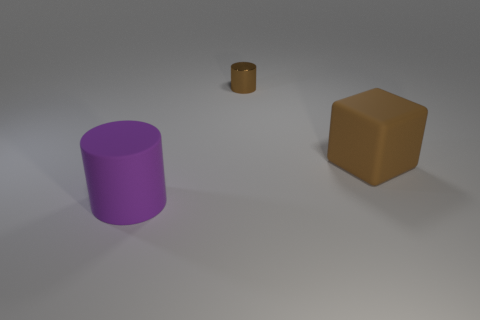Is there any other thing that is made of the same material as the small cylinder?
Make the answer very short. No. Is there any other thing that is the same size as the brown metal cylinder?
Provide a short and direct response. No. What material is the cylinder that is the same size as the brown matte cube?
Provide a short and direct response. Rubber. What shape is the matte object that is behind the object that is on the left side of the brown metal thing that is behind the rubber block?
Give a very brief answer. Cube. What is the shape of the rubber object that is the same size as the rubber cylinder?
Your response must be concise. Cube. There is a matte thing that is in front of the rubber object that is to the right of the tiny thing; what number of cylinders are to the right of it?
Offer a very short reply. 1. Is the number of cylinders right of the purple matte cylinder greater than the number of purple matte objects that are on the right side of the brown rubber thing?
Offer a terse response. Yes. What number of tiny brown things have the same shape as the large brown thing?
Make the answer very short. 0. What number of objects are either brown things that are on the right side of the tiny brown metal cylinder or large brown matte cubes that are on the right side of the large purple rubber cylinder?
Provide a short and direct response. 1. What material is the cylinder behind the big thing that is in front of the thing that is to the right of the brown shiny cylinder?
Your answer should be very brief. Metal. 